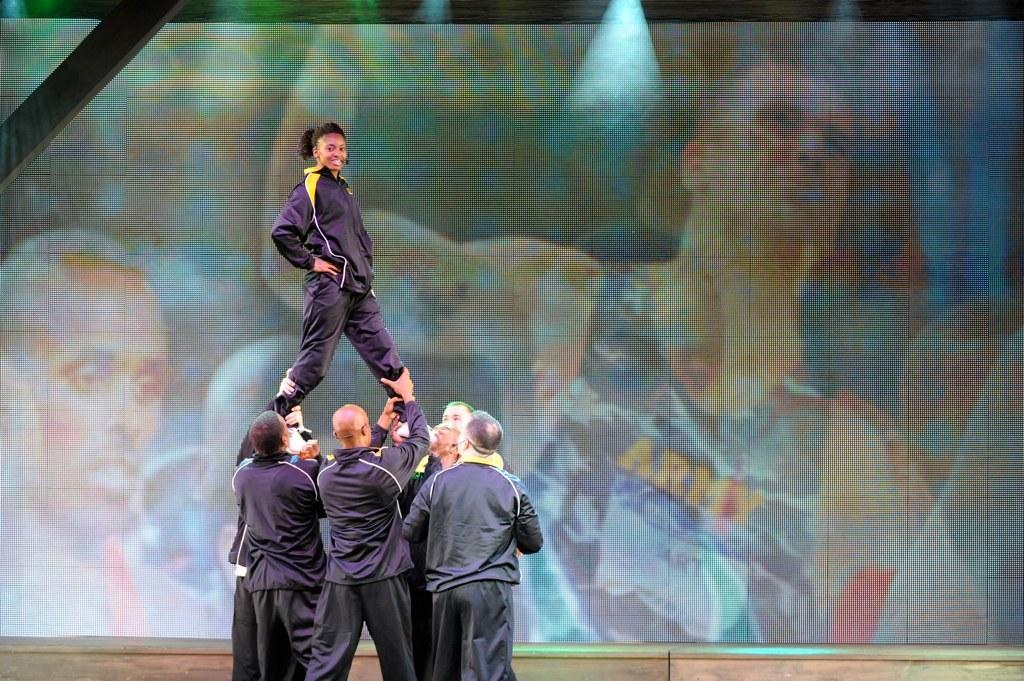What is happening with the people in the image? There are people standing in the image, and a woman is standing on them. How are the people supporting the woman? Some people are holding the woman in the image. What can be seen in the background of the image? There is a screen displaying something in the background. What type of fear is the woman experiencing while standing on the people? There is no indication of fear in the image, and the woman's emotions cannot be determined. What kind of leather material is visible in the image? There is no leather material present in the image. 